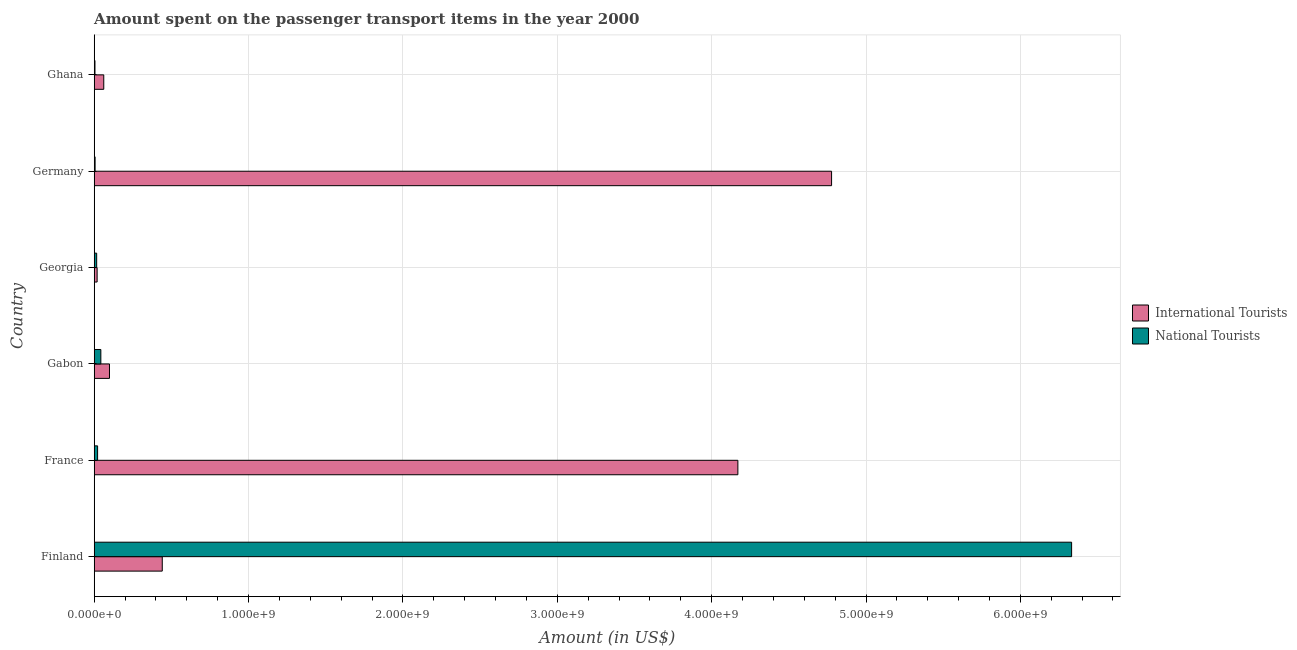How many groups of bars are there?
Keep it short and to the point. 6. Are the number of bars per tick equal to the number of legend labels?
Offer a terse response. Yes. Are the number of bars on each tick of the Y-axis equal?
Offer a very short reply. Yes. What is the amount spent on transport items of international tourists in Georgia?
Your answer should be very brief. 1.90e+07. Across all countries, what is the maximum amount spent on transport items of national tourists?
Offer a terse response. 6.33e+09. Across all countries, what is the minimum amount spent on transport items of international tourists?
Your answer should be compact. 1.90e+07. What is the total amount spent on transport items of international tourists in the graph?
Provide a succinct answer. 9.57e+09. What is the difference between the amount spent on transport items of national tourists in Germany and that in Ghana?
Your answer should be compact. 8.00e+05. What is the difference between the amount spent on transport items of national tourists in Georgia and the amount spent on transport items of international tourists in France?
Keep it short and to the point. -4.15e+09. What is the average amount spent on transport items of national tourists per country?
Provide a short and direct response. 1.07e+09. What is the difference between the amount spent on transport items of national tourists and amount spent on transport items of international tourists in Georgia?
Offer a terse response. -3.00e+06. What is the ratio of the amount spent on transport items of national tourists in Germany to that in Ghana?
Your answer should be compact. 1.16. Is the amount spent on transport items of international tourists in France less than that in Georgia?
Offer a terse response. No. Is the difference between the amount spent on transport items of international tourists in Gabon and Georgia greater than the difference between the amount spent on transport items of national tourists in Gabon and Georgia?
Keep it short and to the point. Yes. What is the difference between the highest and the second highest amount spent on transport items of international tourists?
Your answer should be compact. 6.07e+08. What is the difference between the highest and the lowest amount spent on transport items of international tourists?
Provide a short and direct response. 4.76e+09. What does the 2nd bar from the top in Finland represents?
Your answer should be compact. International Tourists. What does the 2nd bar from the bottom in Gabon represents?
Your response must be concise. National Tourists. What is the difference between two consecutive major ticks on the X-axis?
Provide a succinct answer. 1.00e+09. Does the graph contain any zero values?
Give a very brief answer. No. Where does the legend appear in the graph?
Ensure brevity in your answer.  Center right. How are the legend labels stacked?
Give a very brief answer. Vertical. What is the title of the graph?
Keep it short and to the point. Amount spent on the passenger transport items in the year 2000. Does "GDP per capita" appear as one of the legend labels in the graph?
Ensure brevity in your answer.  No. What is the label or title of the X-axis?
Offer a terse response. Amount (in US$). What is the Amount (in US$) in International Tourists in Finland?
Your answer should be compact. 4.41e+08. What is the Amount (in US$) of National Tourists in Finland?
Your answer should be very brief. 6.33e+09. What is the Amount (in US$) of International Tourists in France?
Ensure brevity in your answer.  4.17e+09. What is the Amount (in US$) in National Tourists in France?
Ensure brevity in your answer.  2.20e+07. What is the Amount (in US$) in International Tourists in Gabon?
Make the answer very short. 9.90e+07. What is the Amount (in US$) of National Tourists in Gabon?
Your answer should be very brief. 4.30e+07. What is the Amount (in US$) of International Tourists in Georgia?
Your answer should be compact. 1.90e+07. What is the Amount (in US$) in National Tourists in Georgia?
Your response must be concise. 1.60e+07. What is the Amount (in US$) of International Tourists in Germany?
Your response must be concise. 4.78e+09. What is the Amount (in US$) in National Tourists in Germany?
Keep it short and to the point. 5.80e+06. What is the Amount (in US$) in International Tourists in Ghana?
Your answer should be very brief. 6.20e+07. Across all countries, what is the maximum Amount (in US$) in International Tourists?
Keep it short and to the point. 4.78e+09. Across all countries, what is the maximum Amount (in US$) of National Tourists?
Ensure brevity in your answer.  6.33e+09. Across all countries, what is the minimum Amount (in US$) in International Tourists?
Your response must be concise. 1.90e+07. Across all countries, what is the minimum Amount (in US$) in National Tourists?
Make the answer very short. 5.00e+06. What is the total Amount (in US$) of International Tourists in the graph?
Provide a short and direct response. 9.57e+09. What is the total Amount (in US$) of National Tourists in the graph?
Keep it short and to the point. 6.42e+09. What is the difference between the Amount (in US$) of International Tourists in Finland and that in France?
Make the answer very short. -3.73e+09. What is the difference between the Amount (in US$) in National Tourists in Finland and that in France?
Offer a very short reply. 6.31e+09. What is the difference between the Amount (in US$) in International Tourists in Finland and that in Gabon?
Offer a terse response. 3.42e+08. What is the difference between the Amount (in US$) of National Tourists in Finland and that in Gabon?
Provide a succinct answer. 6.29e+09. What is the difference between the Amount (in US$) in International Tourists in Finland and that in Georgia?
Your response must be concise. 4.22e+08. What is the difference between the Amount (in US$) in National Tourists in Finland and that in Georgia?
Keep it short and to the point. 6.32e+09. What is the difference between the Amount (in US$) of International Tourists in Finland and that in Germany?
Your answer should be very brief. -4.34e+09. What is the difference between the Amount (in US$) in National Tourists in Finland and that in Germany?
Provide a succinct answer. 6.33e+09. What is the difference between the Amount (in US$) in International Tourists in Finland and that in Ghana?
Provide a succinct answer. 3.79e+08. What is the difference between the Amount (in US$) in National Tourists in Finland and that in Ghana?
Provide a succinct answer. 6.33e+09. What is the difference between the Amount (in US$) of International Tourists in France and that in Gabon?
Provide a succinct answer. 4.07e+09. What is the difference between the Amount (in US$) of National Tourists in France and that in Gabon?
Your answer should be very brief. -2.10e+07. What is the difference between the Amount (in US$) of International Tourists in France and that in Georgia?
Offer a very short reply. 4.15e+09. What is the difference between the Amount (in US$) in International Tourists in France and that in Germany?
Offer a terse response. -6.07e+08. What is the difference between the Amount (in US$) in National Tourists in France and that in Germany?
Your answer should be very brief. 1.62e+07. What is the difference between the Amount (in US$) in International Tourists in France and that in Ghana?
Your response must be concise. 4.11e+09. What is the difference between the Amount (in US$) in National Tourists in France and that in Ghana?
Give a very brief answer. 1.70e+07. What is the difference between the Amount (in US$) of International Tourists in Gabon and that in Georgia?
Ensure brevity in your answer.  8.00e+07. What is the difference between the Amount (in US$) of National Tourists in Gabon and that in Georgia?
Make the answer very short. 2.70e+07. What is the difference between the Amount (in US$) in International Tourists in Gabon and that in Germany?
Offer a terse response. -4.68e+09. What is the difference between the Amount (in US$) in National Tourists in Gabon and that in Germany?
Your answer should be very brief. 3.72e+07. What is the difference between the Amount (in US$) of International Tourists in Gabon and that in Ghana?
Your answer should be very brief. 3.70e+07. What is the difference between the Amount (in US$) of National Tourists in Gabon and that in Ghana?
Give a very brief answer. 3.80e+07. What is the difference between the Amount (in US$) in International Tourists in Georgia and that in Germany?
Offer a very short reply. -4.76e+09. What is the difference between the Amount (in US$) in National Tourists in Georgia and that in Germany?
Your answer should be compact. 1.02e+07. What is the difference between the Amount (in US$) in International Tourists in Georgia and that in Ghana?
Your response must be concise. -4.30e+07. What is the difference between the Amount (in US$) of National Tourists in Georgia and that in Ghana?
Give a very brief answer. 1.10e+07. What is the difference between the Amount (in US$) in International Tourists in Germany and that in Ghana?
Ensure brevity in your answer.  4.72e+09. What is the difference between the Amount (in US$) in National Tourists in Germany and that in Ghana?
Your answer should be very brief. 8.00e+05. What is the difference between the Amount (in US$) in International Tourists in Finland and the Amount (in US$) in National Tourists in France?
Keep it short and to the point. 4.19e+08. What is the difference between the Amount (in US$) in International Tourists in Finland and the Amount (in US$) in National Tourists in Gabon?
Your answer should be very brief. 3.98e+08. What is the difference between the Amount (in US$) of International Tourists in Finland and the Amount (in US$) of National Tourists in Georgia?
Your answer should be very brief. 4.25e+08. What is the difference between the Amount (in US$) of International Tourists in Finland and the Amount (in US$) of National Tourists in Germany?
Ensure brevity in your answer.  4.35e+08. What is the difference between the Amount (in US$) of International Tourists in Finland and the Amount (in US$) of National Tourists in Ghana?
Keep it short and to the point. 4.36e+08. What is the difference between the Amount (in US$) of International Tourists in France and the Amount (in US$) of National Tourists in Gabon?
Give a very brief answer. 4.13e+09. What is the difference between the Amount (in US$) of International Tourists in France and the Amount (in US$) of National Tourists in Georgia?
Offer a terse response. 4.15e+09. What is the difference between the Amount (in US$) of International Tourists in France and the Amount (in US$) of National Tourists in Germany?
Your answer should be compact. 4.16e+09. What is the difference between the Amount (in US$) of International Tourists in France and the Amount (in US$) of National Tourists in Ghana?
Offer a terse response. 4.16e+09. What is the difference between the Amount (in US$) of International Tourists in Gabon and the Amount (in US$) of National Tourists in Georgia?
Offer a very short reply. 8.30e+07. What is the difference between the Amount (in US$) in International Tourists in Gabon and the Amount (in US$) in National Tourists in Germany?
Offer a terse response. 9.32e+07. What is the difference between the Amount (in US$) in International Tourists in Gabon and the Amount (in US$) in National Tourists in Ghana?
Give a very brief answer. 9.40e+07. What is the difference between the Amount (in US$) in International Tourists in Georgia and the Amount (in US$) in National Tourists in Germany?
Offer a very short reply. 1.32e+07. What is the difference between the Amount (in US$) in International Tourists in Georgia and the Amount (in US$) in National Tourists in Ghana?
Keep it short and to the point. 1.40e+07. What is the difference between the Amount (in US$) in International Tourists in Germany and the Amount (in US$) in National Tourists in Ghana?
Provide a short and direct response. 4.77e+09. What is the average Amount (in US$) of International Tourists per country?
Make the answer very short. 1.59e+09. What is the average Amount (in US$) of National Tourists per country?
Your answer should be compact. 1.07e+09. What is the difference between the Amount (in US$) in International Tourists and Amount (in US$) in National Tourists in Finland?
Your answer should be compact. -5.89e+09. What is the difference between the Amount (in US$) of International Tourists and Amount (in US$) of National Tourists in France?
Your response must be concise. 4.15e+09. What is the difference between the Amount (in US$) in International Tourists and Amount (in US$) in National Tourists in Gabon?
Provide a succinct answer. 5.60e+07. What is the difference between the Amount (in US$) of International Tourists and Amount (in US$) of National Tourists in Germany?
Offer a terse response. 4.77e+09. What is the difference between the Amount (in US$) of International Tourists and Amount (in US$) of National Tourists in Ghana?
Make the answer very short. 5.70e+07. What is the ratio of the Amount (in US$) in International Tourists in Finland to that in France?
Give a very brief answer. 0.11. What is the ratio of the Amount (in US$) of National Tourists in Finland to that in France?
Give a very brief answer. 287.82. What is the ratio of the Amount (in US$) of International Tourists in Finland to that in Gabon?
Give a very brief answer. 4.45. What is the ratio of the Amount (in US$) of National Tourists in Finland to that in Gabon?
Ensure brevity in your answer.  147.26. What is the ratio of the Amount (in US$) in International Tourists in Finland to that in Georgia?
Offer a terse response. 23.21. What is the ratio of the Amount (in US$) of National Tourists in Finland to that in Georgia?
Ensure brevity in your answer.  395.75. What is the ratio of the Amount (in US$) of International Tourists in Finland to that in Germany?
Your answer should be very brief. 0.09. What is the ratio of the Amount (in US$) of National Tourists in Finland to that in Germany?
Give a very brief answer. 1091.72. What is the ratio of the Amount (in US$) of International Tourists in Finland to that in Ghana?
Your answer should be very brief. 7.11. What is the ratio of the Amount (in US$) in National Tourists in Finland to that in Ghana?
Your response must be concise. 1266.4. What is the ratio of the Amount (in US$) of International Tourists in France to that in Gabon?
Your answer should be very brief. 42.12. What is the ratio of the Amount (in US$) of National Tourists in France to that in Gabon?
Offer a terse response. 0.51. What is the ratio of the Amount (in US$) in International Tourists in France to that in Georgia?
Offer a very short reply. 219.47. What is the ratio of the Amount (in US$) in National Tourists in France to that in Georgia?
Your response must be concise. 1.38. What is the ratio of the Amount (in US$) in International Tourists in France to that in Germany?
Offer a very short reply. 0.87. What is the ratio of the Amount (in US$) in National Tourists in France to that in Germany?
Your answer should be very brief. 3.79. What is the ratio of the Amount (in US$) in International Tourists in France to that in Ghana?
Keep it short and to the point. 67.26. What is the ratio of the Amount (in US$) of International Tourists in Gabon to that in Georgia?
Your answer should be compact. 5.21. What is the ratio of the Amount (in US$) in National Tourists in Gabon to that in Georgia?
Your response must be concise. 2.69. What is the ratio of the Amount (in US$) in International Tourists in Gabon to that in Germany?
Make the answer very short. 0.02. What is the ratio of the Amount (in US$) of National Tourists in Gabon to that in Germany?
Keep it short and to the point. 7.41. What is the ratio of the Amount (in US$) of International Tourists in Gabon to that in Ghana?
Keep it short and to the point. 1.6. What is the ratio of the Amount (in US$) in International Tourists in Georgia to that in Germany?
Provide a succinct answer. 0. What is the ratio of the Amount (in US$) in National Tourists in Georgia to that in Germany?
Keep it short and to the point. 2.76. What is the ratio of the Amount (in US$) of International Tourists in Georgia to that in Ghana?
Make the answer very short. 0.31. What is the ratio of the Amount (in US$) in International Tourists in Germany to that in Ghana?
Ensure brevity in your answer.  77.05. What is the ratio of the Amount (in US$) of National Tourists in Germany to that in Ghana?
Your answer should be very brief. 1.16. What is the difference between the highest and the second highest Amount (in US$) of International Tourists?
Ensure brevity in your answer.  6.07e+08. What is the difference between the highest and the second highest Amount (in US$) in National Tourists?
Offer a very short reply. 6.29e+09. What is the difference between the highest and the lowest Amount (in US$) in International Tourists?
Keep it short and to the point. 4.76e+09. What is the difference between the highest and the lowest Amount (in US$) in National Tourists?
Offer a terse response. 6.33e+09. 